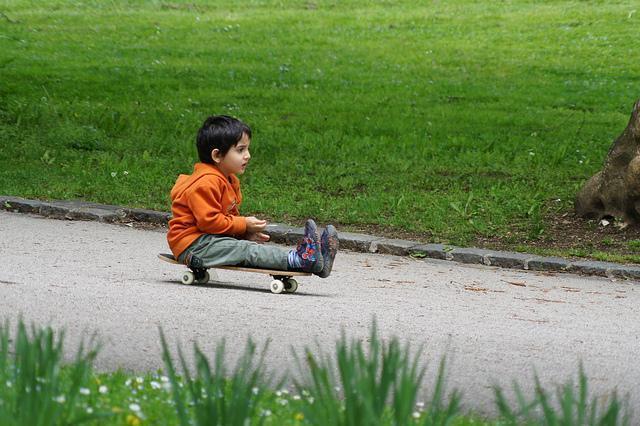How many people do you see?
Give a very brief answer. 1. 